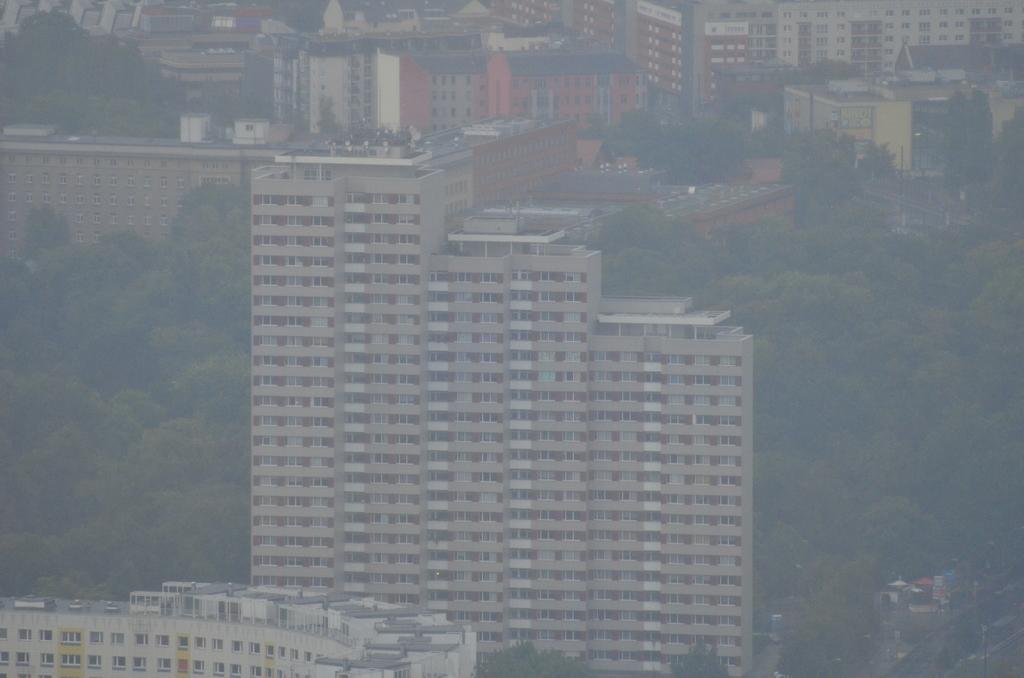How would you summarize this image in a sentence or two? In this image, there are a few buildings, trees. We can see the ground and some objects on the bottom right corner. 